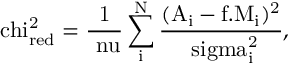Convert formula to latex. <formula><loc_0><loc_0><loc_500><loc_500>\ c h i _ { r e d } ^ { 2 } = \frac { 1 } { \ n u } \sum _ { i } ^ { N } \frac { ( A _ { i } - f . M _ { i } ) ^ { 2 } } { \ s i g m a _ { i } ^ { 2 } } ,</formula> 